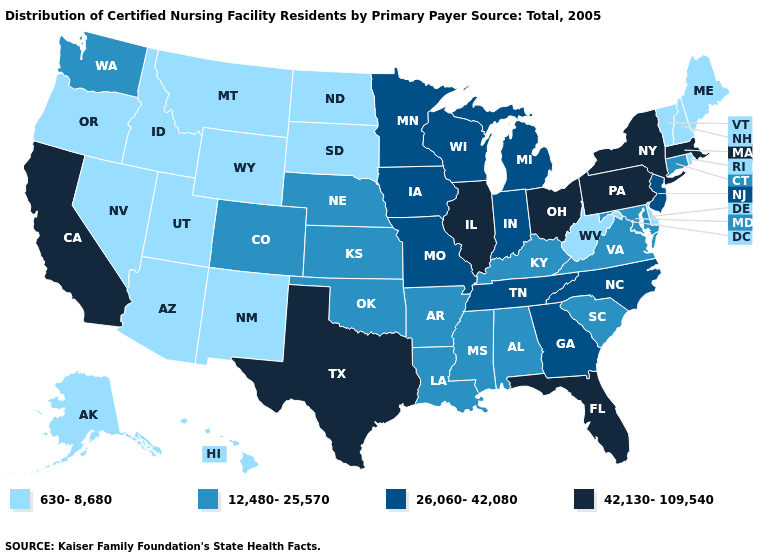Name the states that have a value in the range 42,130-109,540?
Give a very brief answer. California, Florida, Illinois, Massachusetts, New York, Ohio, Pennsylvania, Texas. What is the highest value in the West ?
Concise answer only. 42,130-109,540. Among the states that border Arizona , which have the lowest value?
Give a very brief answer. Nevada, New Mexico, Utah. What is the highest value in the MidWest ?
Quick response, please. 42,130-109,540. Name the states that have a value in the range 26,060-42,080?
Answer briefly. Georgia, Indiana, Iowa, Michigan, Minnesota, Missouri, New Jersey, North Carolina, Tennessee, Wisconsin. What is the value of Utah?
Answer briefly. 630-8,680. Name the states that have a value in the range 26,060-42,080?
Give a very brief answer. Georgia, Indiana, Iowa, Michigan, Minnesota, Missouri, New Jersey, North Carolina, Tennessee, Wisconsin. Does Mississippi have the lowest value in the USA?
Answer briefly. No. What is the value of Utah?
Be succinct. 630-8,680. Name the states that have a value in the range 12,480-25,570?
Answer briefly. Alabama, Arkansas, Colorado, Connecticut, Kansas, Kentucky, Louisiana, Maryland, Mississippi, Nebraska, Oklahoma, South Carolina, Virginia, Washington. What is the value of Iowa?
Write a very short answer. 26,060-42,080. Does Wyoming have a lower value than North Dakota?
Write a very short answer. No. Which states have the lowest value in the South?
Be succinct. Delaware, West Virginia. What is the lowest value in the South?
Give a very brief answer. 630-8,680. What is the value of Maryland?
Quick response, please. 12,480-25,570. 